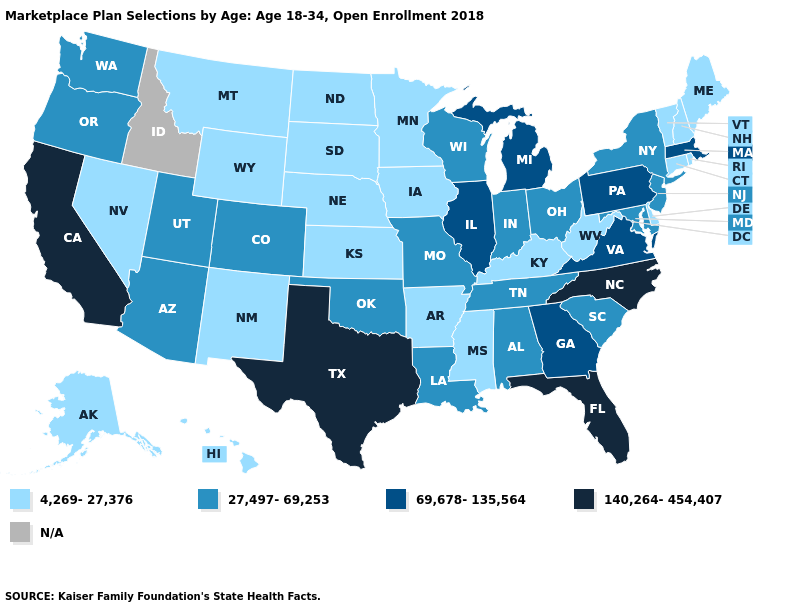Which states have the highest value in the USA?
Concise answer only. California, Florida, North Carolina, Texas. Name the states that have a value in the range 27,497-69,253?
Give a very brief answer. Alabama, Arizona, Colorado, Indiana, Louisiana, Maryland, Missouri, New Jersey, New York, Ohio, Oklahoma, Oregon, South Carolina, Tennessee, Utah, Washington, Wisconsin. What is the lowest value in the Northeast?
Give a very brief answer. 4,269-27,376. Name the states that have a value in the range 27,497-69,253?
Answer briefly. Alabama, Arizona, Colorado, Indiana, Louisiana, Maryland, Missouri, New Jersey, New York, Ohio, Oklahoma, Oregon, South Carolina, Tennessee, Utah, Washington, Wisconsin. Name the states that have a value in the range 69,678-135,564?
Answer briefly. Georgia, Illinois, Massachusetts, Michigan, Pennsylvania, Virginia. What is the value of South Carolina?
Write a very short answer. 27,497-69,253. What is the lowest value in states that border West Virginia?
Concise answer only. 4,269-27,376. Name the states that have a value in the range 140,264-454,407?
Give a very brief answer. California, Florida, North Carolina, Texas. Name the states that have a value in the range 69,678-135,564?
Answer briefly. Georgia, Illinois, Massachusetts, Michigan, Pennsylvania, Virginia. Does the map have missing data?
Keep it brief. Yes. What is the value of Louisiana?
Write a very short answer. 27,497-69,253. Name the states that have a value in the range N/A?
Keep it brief. Idaho. Which states have the highest value in the USA?
Short answer required. California, Florida, North Carolina, Texas. Name the states that have a value in the range 69,678-135,564?
Quick response, please. Georgia, Illinois, Massachusetts, Michigan, Pennsylvania, Virginia. 